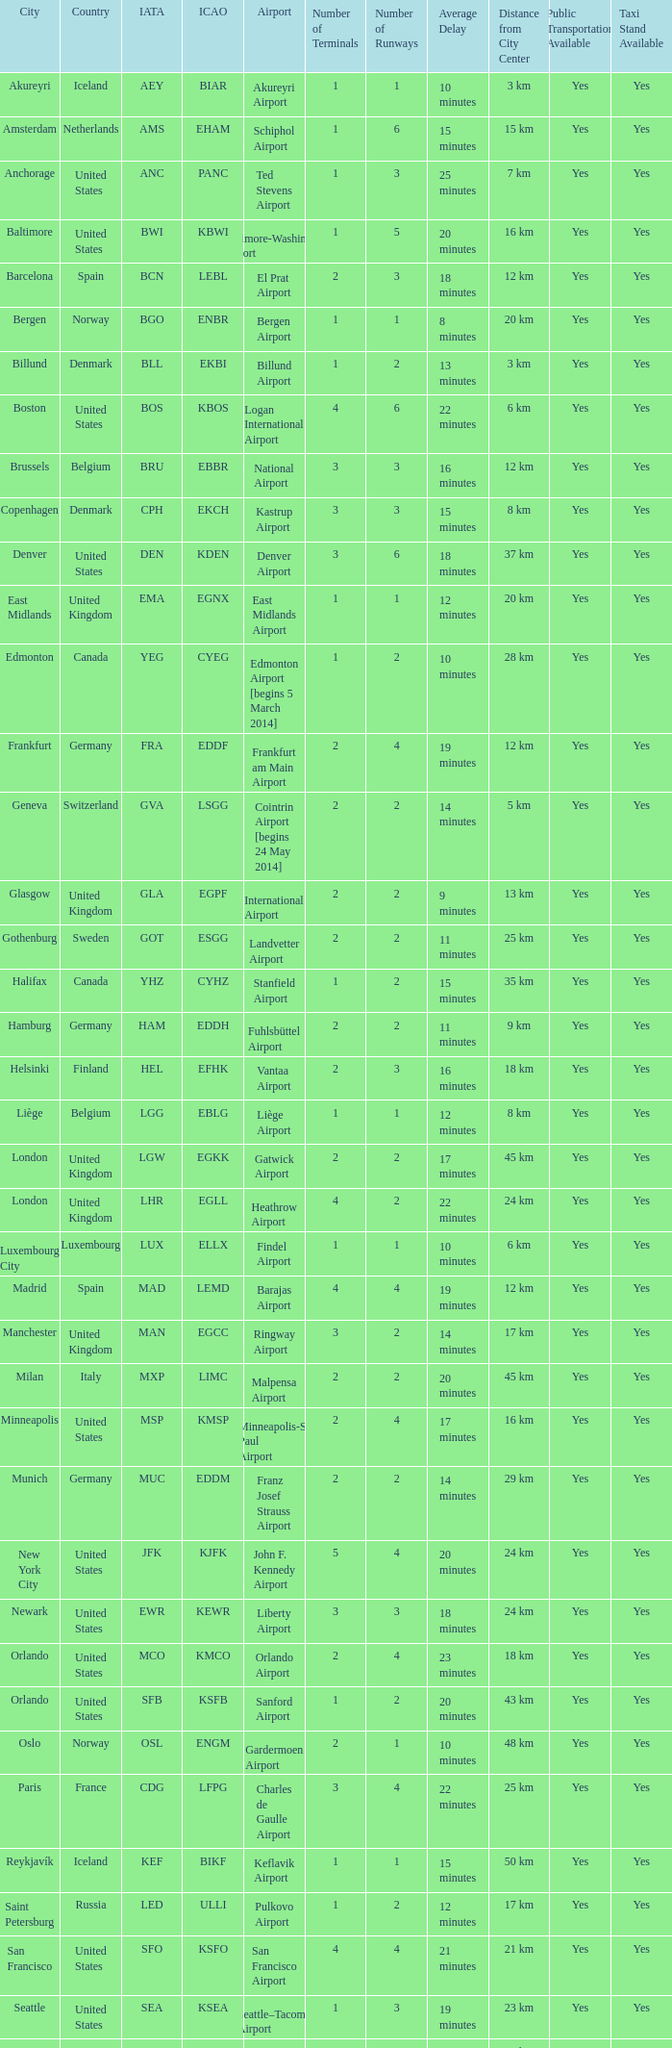What is the City with an IATA of MUC? Munich. 